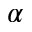Convert formula to latex. <formula><loc_0><loc_0><loc_500><loc_500>\alpha</formula> 